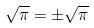Convert formula to latex. <formula><loc_0><loc_0><loc_500><loc_500>\sqrt { \pi } = \pm \sqrt { \pi }</formula> 